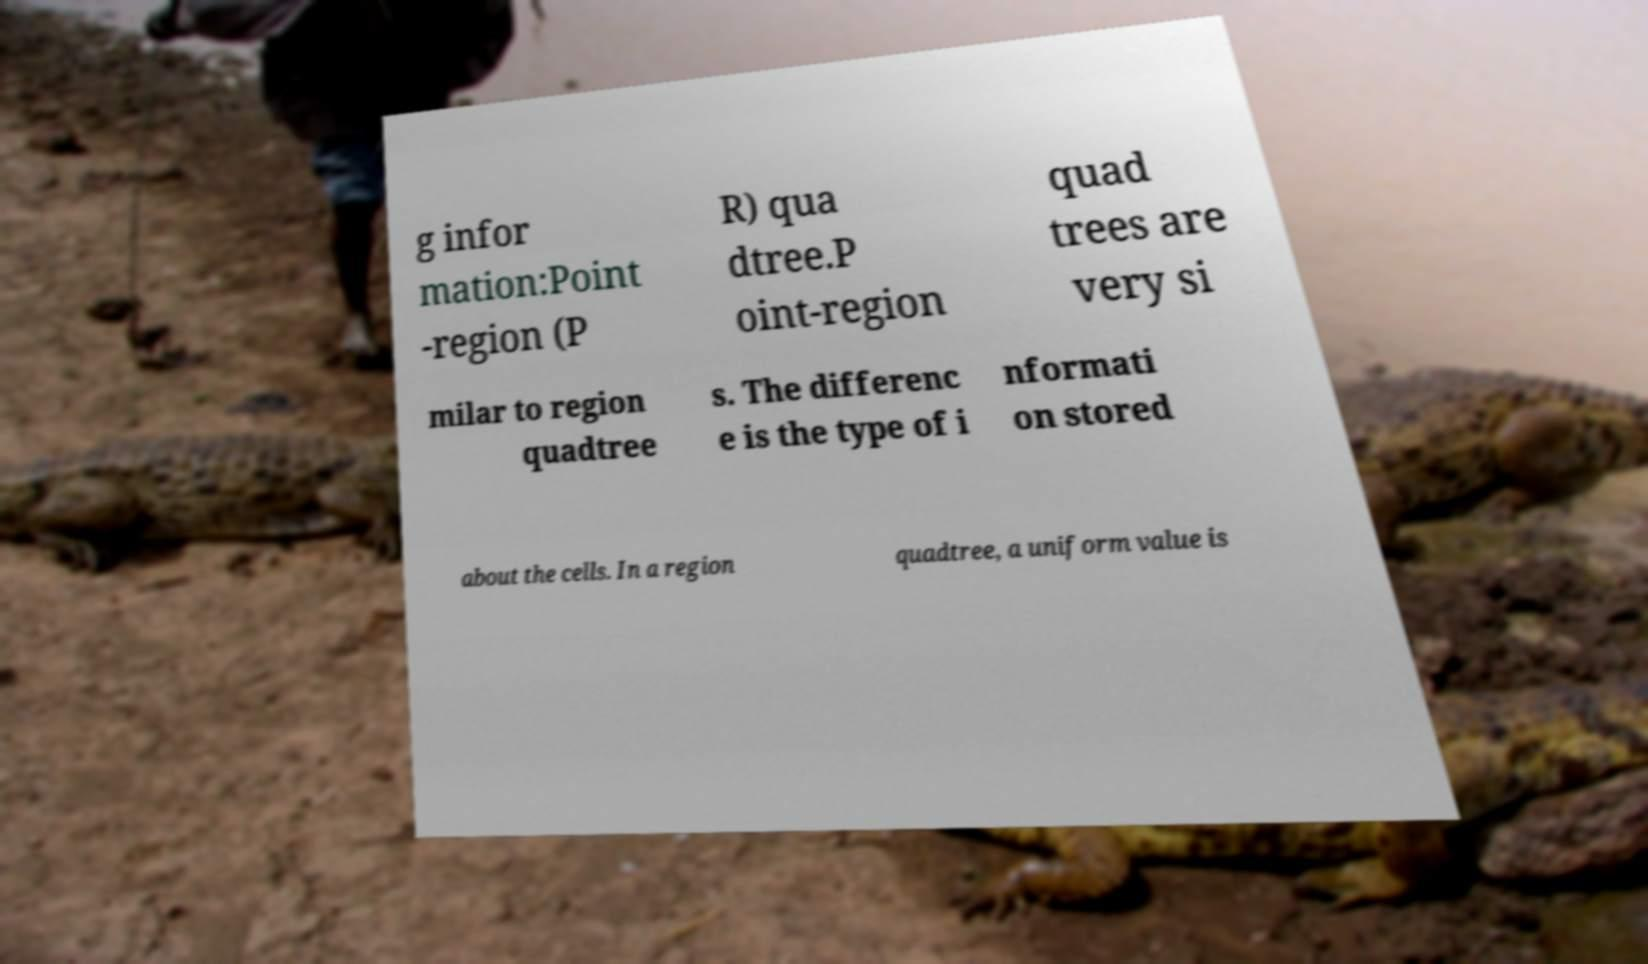For documentation purposes, I need the text within this image transcribed. Could you provide that? g infor mation:Point -region (P R) qua dtree.P oint-region quad trees are very si milar to region quadtree s. The differenc e is the type of i nformati on stored about the cells. In a region quadtree, a uniform value is 